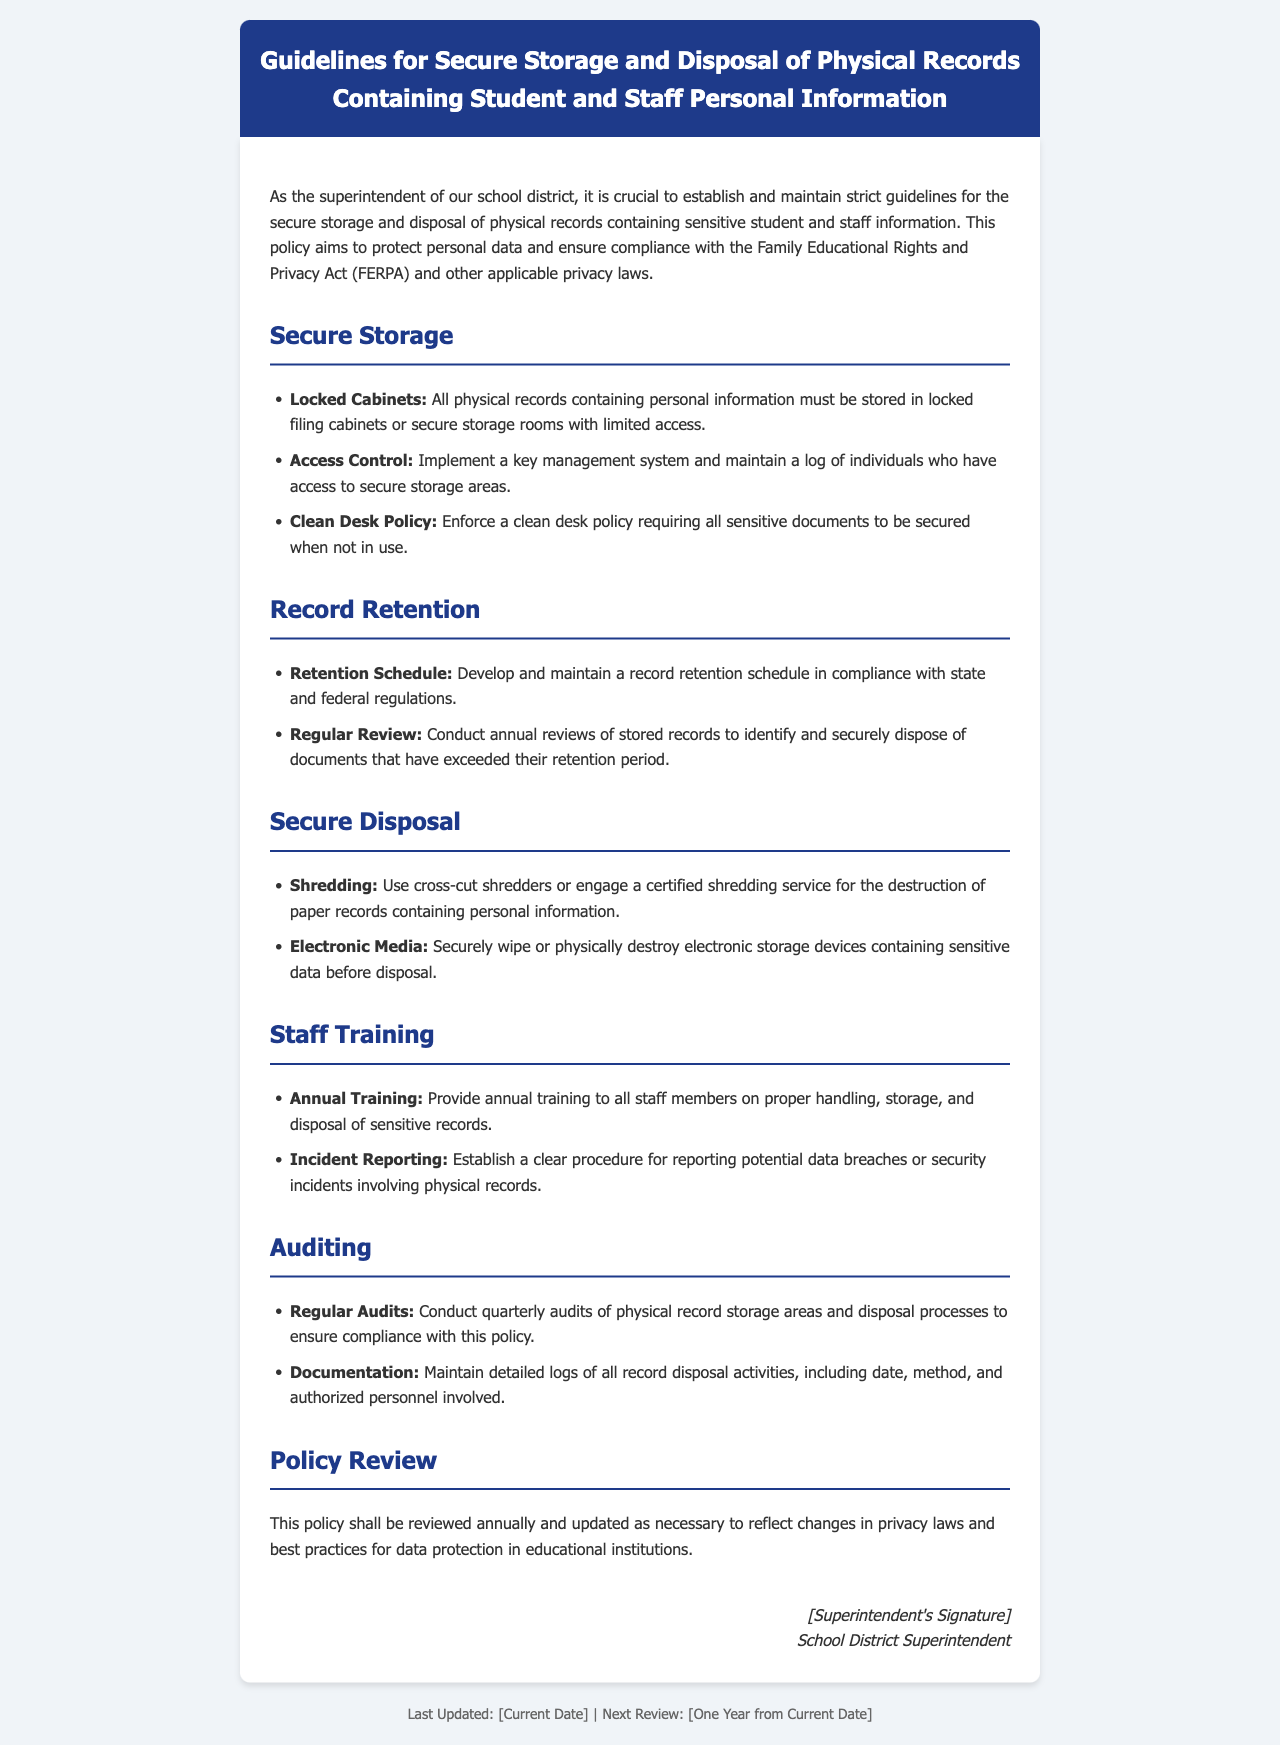What is the title of the document? The title is prominently displayed at the top of the document.
Answer: Guidelines for Secure Storage and Disposal of Physical Records Containing Student and Staff Personal Information What must physical records be stored in? The document specifies the type of storage required for physical records.
Answer: Locked filing cabinets What is the frequency of record audits mentioned? The policy states how often audits should occur to maintain compliance.
Answer: Quarterly What is the method recommended for disposing of paper records? The document suggests a specific procedure for the destruction of paper records containing personal information.
Answer: Shredding What type of training is required for staff? The document outlines the type of training that needs to be provided to staff regarding sensitive records.
Answer: Annual Training What should be developed in compliance with state and federal regulations? The policy requires a specific document that must be maintained according to legal standards.
Answer: Retention Schedule What should be securely wiped or destroyed before disposal? The policy includes a directive regarding electronic storage devices.
Answer: Electronic storage devices How often should the policy be reviewed? The document indicates the frequency at which the policy itself should be revisited and potentially updated.
Answer: Annually 